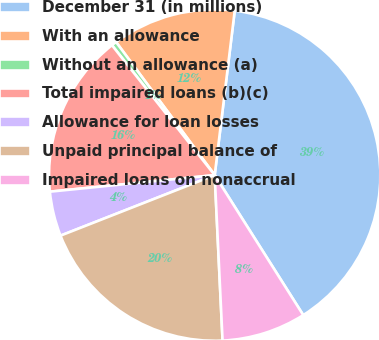Convert chart to OTSL. <chart><loc_0><loc_0><loc_500><loc_500><pie_chart><fcel>December 31 (in millions)<fcel>With an allowance<fcel>Without an allowance (a)<fcel>Total impaired loans (b)(c)<fcel>Allowance for loan losses<fcel>Unpaid principal balance of<fcel>Impaired loans on nonaccrual<nl><fcel>39.09%<fcel>12.08%<fcel>0.5%<fcel>15.94%<fcel>4.36%<fcel>19.8%<fcel>8.22%<nl></chart> 